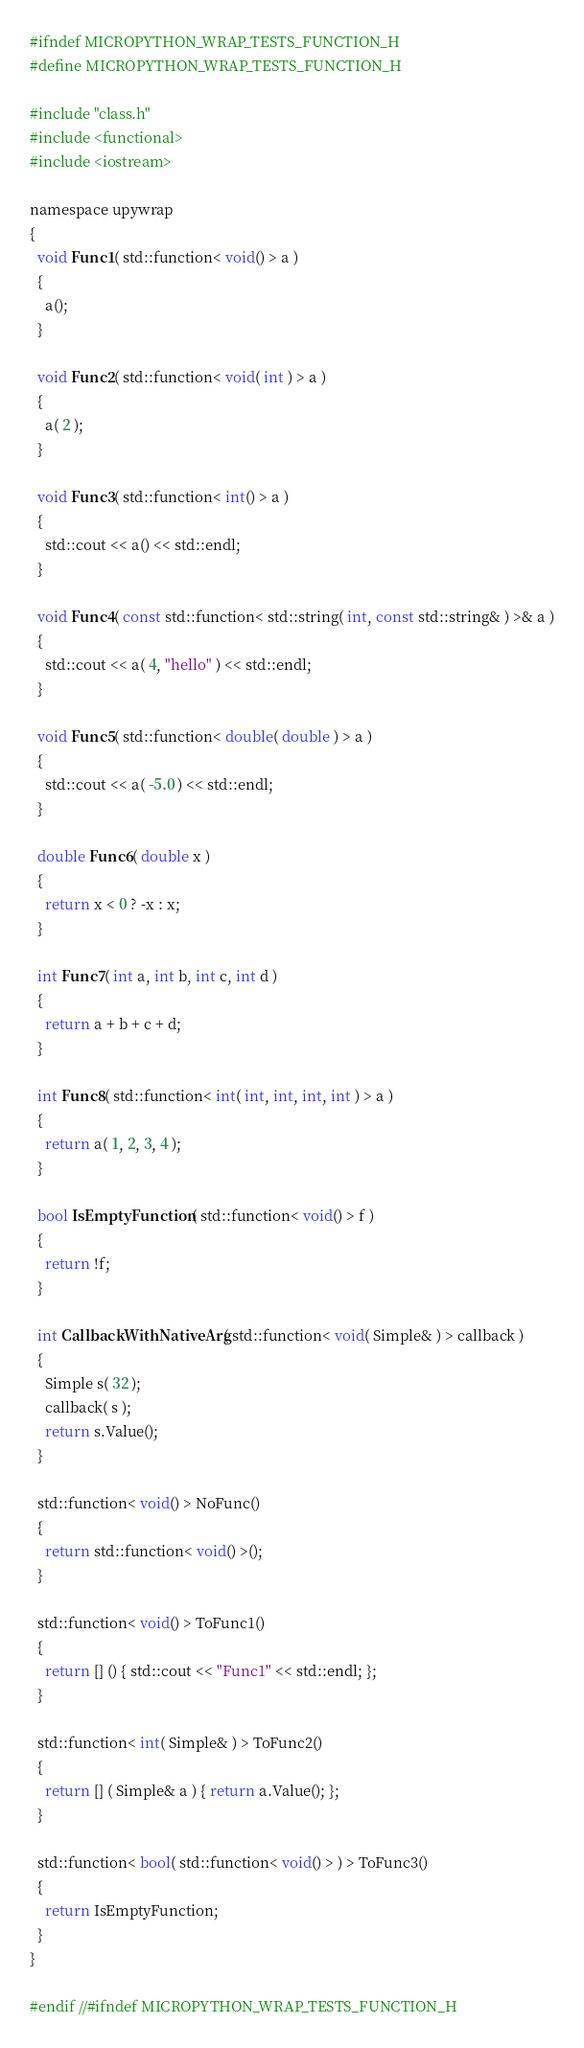Convert code to text. <code><loc_0><loc_0><loc_500><loc_500><_C_>#ifndef MICROPYTHON_WRAP_TESTS_FUNCTION_H
#define MICROPYTHON_WRAP_TESTS_FUNCTION_H

#include "class.h"
#include <functional>
#include <iostream>

namespace upywrap
{
  void Func1( std::function< void() > a )
  {
    a();
  }

  void Func2( std::function< void( int ) > a )
  {
    a( 2 );
  }

  void Func3( std::function< int() > a )
  {
    std::cout << a() << std::endl;
  }

  void Func4( const std::function< std::string( int, const std::string& ) >& a )
  {
    std::cout << a( 4, "hello" ) << std::endl;
  }

  void Func5( std::function< double( double ) > a )
  {
    std::cout << a( -5.0 ) << std::endl;
  }

  double Func6( double x )
  {
    return x < 0 ? -x : x;
  }

  int Func7( int a, int b, int c, int d )
  {
    return a + b + c + d;
  }

  int Func8( std::function< int( int, int, int, int ) > a )
  {
    return a( 1, 2, 3, 4 );
  }

  bool IsEmptyFunction( std::function< void() > f )
  {
    return !f;
  }

  int CallbackWithNativeArg( std::function< void( Simple& ) > callback )
  {
    Simple s( 32 );
    callback( s );
    return s.Value();
  }

  std::function< void() > NoFunc()
  {
    return std::function< void() >();
  }

  std::function< void() > ToFunc1()
  {
    return [] () { std::cout << "Func1" << std::endl; };
  }

  std::function< int( Simple& ) > ToFunc2()
  {
    return [] ( Simple& a ) { return a.Value(); };
  }

  std::function< bool( std::function< void() > ) > ToFunc3()
  {
    return IsEmptyFunction;
  }
}

#endif //#ifndef MICROPYTHON_WRAP_TESTS_FUNCTION_H
</code> 